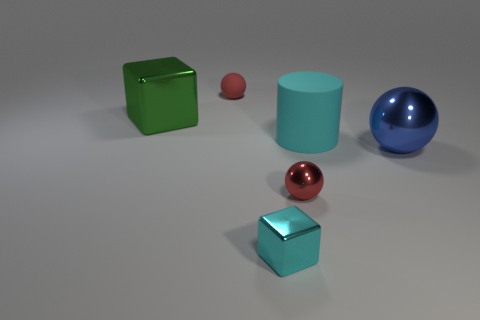Subtract all large balls. How many balls are left? 2 Subtract all red blocks. How many red spheres are left? 2 Add 3 metal balls. How many objects exist? 9 Subtract all cyan cubes. How many cubes are left? 1 Subtract all cubes. How many objects are left? 4 Subtract all red rubber objects. Subtract all tiny yellow rubber blocks. How many objects are left? 5 Add 2 big green objects. How many big green objects are left? 3 Add 2 large metal blocks. How many large metal blocks exist? 3 Subtract 1 cyan cylinders. How many objects are left? 5 Subtract 1 spheres. How many spheres are left? 2 